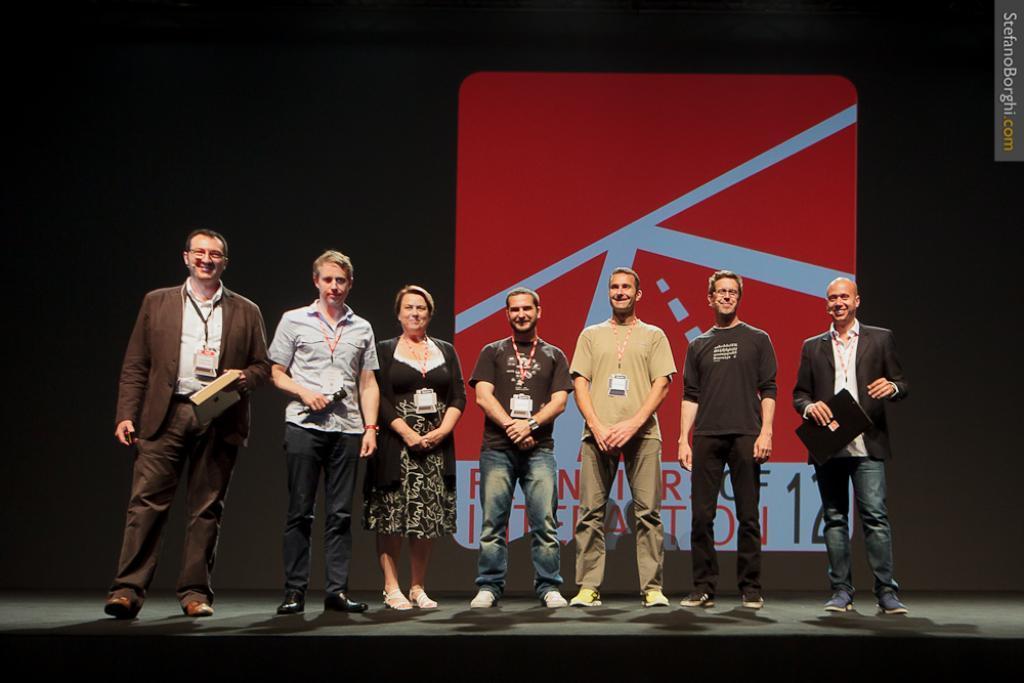In one or two sentences, can you explain what this image depicts? Here men and women are standing wearing clothes and id card. 